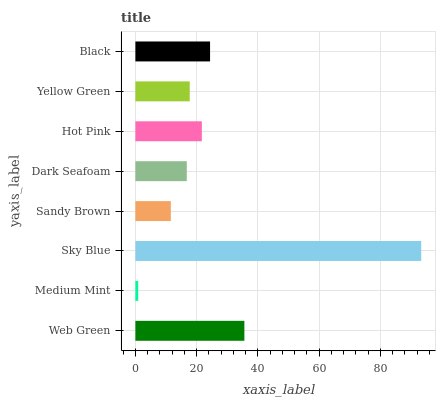Is Medium Mint the minimum?
Answer yes or no. Yes. Is Sky Blue the maximum?
Answer yes or no. Yes. Is Sky Blue the minimum?
Answer yes or no. No. Is Medium Mint the maximum?
Answer yes or no. No. Is Sky Blue greater than Medium Mint?
Answer yes or no. Yes. Is Medium Mint less than Sky Blue?
Answer yes or no. Yes. Is Medium Mint greater than Sky Blue?
Answer yes or no. No. Is Sky Blue less than Medium Mint?
Answer yes or no. No. Is Hot Pink the high median?
Answer yes or no. Yes. Is Yellow Green the low median?
Answer yes or no. Yes. Is Black the high median?
Answer yes or no. No. Is Dark Seafoam the low median?
Answer yes or no. No. 